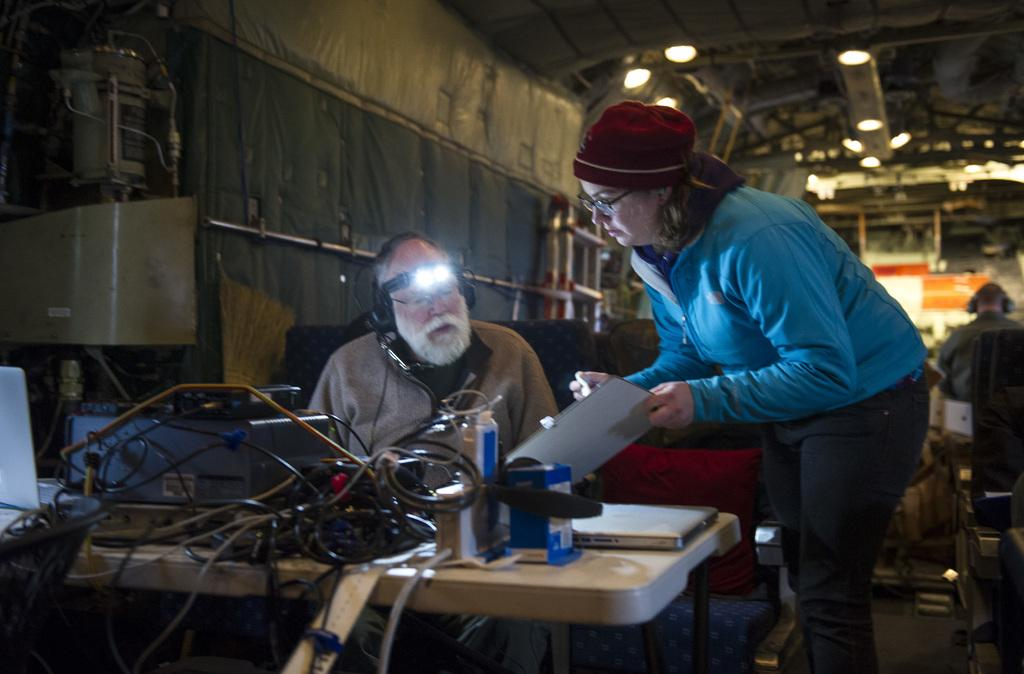How many people are present in the image? There are three people in the image. What is in front of two of the people? There is a table in front of two people. What can be seen on the table? There are wires and a laptop on the table. What can be observed in the background of the image? There are lights visible in the background. What type of cart is being used to transport the bells in the image? There is no cart or bells present in the image. What time of day is depicted in the image, considering the hour? The provided facts do not mention the time of day or any hour-related information, so it cannot be determined from the image. 